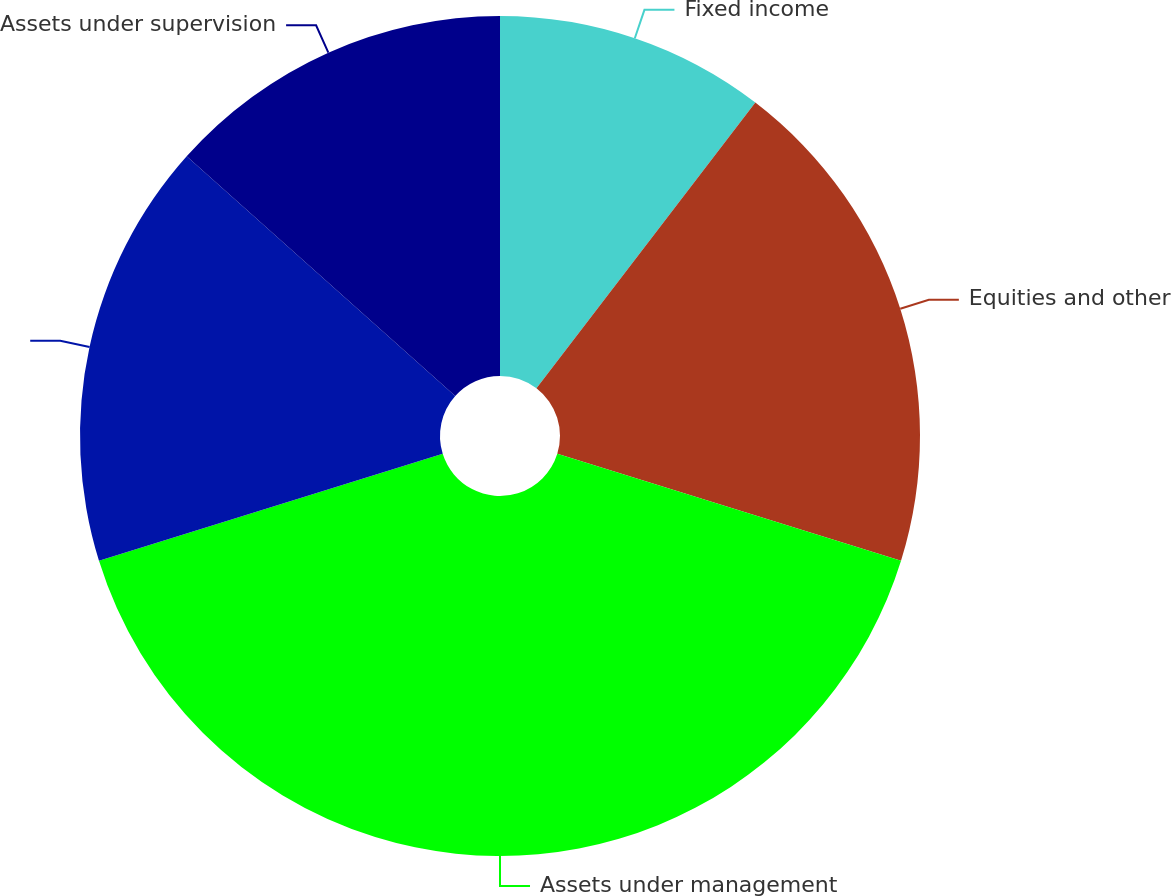Convert chart. <chart><loc_0><loc_0><loc_500><loc_500><pie_chart><fcel>Fixed income<fcel>Equities and other<fcel>Assets under management<fcel>Unnamed: 3<fcel>Assets under supervision<nl><fcel>10.4%<fcel>19.4%<fcel>40.39%<fcel>16.4%<fcel>13.4%<nl></chart> 